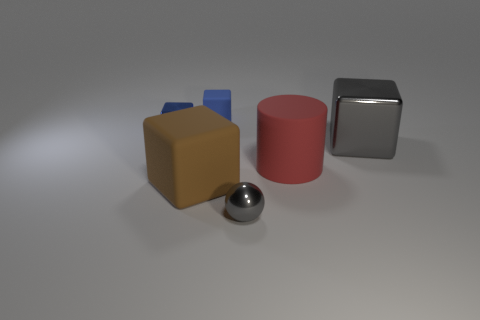Add 2 large red objects. How many objects exist? 8 Subtract all cylinders. How many objects are left? 5 Add 6 large cylinders. How many large cylinders exist? 7 Subtract 1 gray blocks. How many objects are left? 5 Subtract all cyan rubber cubes. Subtract all small blue metal objects. How many objects are left? 5 Add 6 big red things. How many big red things are left? 7 